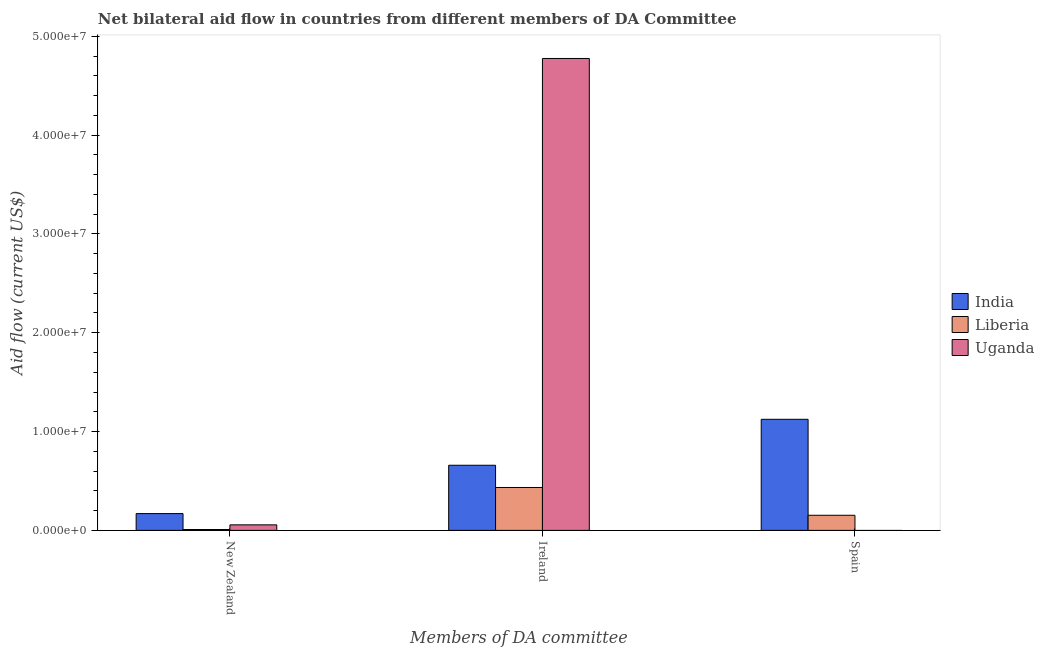How many different coloured bars are there?
Make the answer very short. 3. What is the label of the 2nd group of bars from the left?
Ensure brevity in your answer.  Ireland. What is the amount of aid provided by spain in India?
Make the answer very short. 1.12e+07. Across all countries, what is the maximum amount of aid provided by new zealand?
Your answer should be compact. 1.70e+06. Across all countries, what is the minimum amount of aid provided by ireland?
Make the answer very short. 4.34e+06. In which country was the amount of aid provided by ireland maximum?
Ensure brevity in your answer.  Uganda. What is the total amount of aid provided by new zealand in the graph?
Make the answer very short. 2.35e+06. What is the difference between the amount of aid provided by ireland in India and that in Uganda?
Give a very brief answer. -4.12e+07. What is the difference between the amount of aid provided by spain in Uganda and the amount of aid provided by new zealand in India?
Offer a very short reply. -1.70e+06. What is the average amount of aid provided by spain per country?
Provide a succinct answer. 4.26e+06. What is the difference between the amount of aid provided by spain and amount of aid provided by new zealand in India?
Keep it short and to the point. 9.54e+06. In how many countries, is the amount of aid provided by ireland greater than 28000000 US$?
Make the answer very short. 1. What is the ratio of the amount of aid provided by new zealand in India to that in Liberia?
Your answer should be very brief. 18.89. Is the amount of aid provided by new zealand in Liberia less than that in India?
Ensure brevity in your answer.  Yes. What is the difference between the highest and the second highest amount of aid provided by new zealand?
Provide a short and direct response. 1.14e+06. What is the difference between the highest and the lowest amount of aid provided by ireland?
Offer a very short reply. 4.34e+07. Is the sum of the amount of aid provided by ireland in Liberia and Uganda greater than the maximum amount of aid provided by spain across all countries?
Make the answer very short. Yes. Is it the case that in every country, the sum of the amount of aid provided by new zealand and amount of aid provided by ireland is greater than the amount of aid provided by spain?
Ensure brevity in your answer.  No. How many bars are there?
Your response must be concise. 8. Are all the bars in the graph horizontal?
Your answer should be compact. No. Does the graph contain grids?
Your answer should be very brief. No. Where does the legend appear in the graph?
Your answer should be very brief. Center right. How are the legend labels stacked?
Provide a short and direct response. Vertical. What is the title of the graph?
Provide a short and direct response. Net bilateral aid flow in countries from different members of DA Committee. What is the label or title of the X-axis?
Provide a succinct answer. Members of DA committee. What is the Aid flow (current US$) of India in New Zealand?
Give a very brief answer. 1.70e+06. What is the Aid flow (current US$) in Liberia in New Zealand?
Your answer should be very brief. 9.00e+04. What is the Aid flow (current US$) of Uganda in New Zealand?
Keep it short and to the point. 5.60e+05. What is the Aid flow (current US$) of India in Ireland?
Offer a terse response. 6.59e+06. What is the Aid flow (current US$) in Liberia in Ireland?
Your response must be concise. 4.34e+06. What is the Aid flow (current US$) in Uganda in Ireland?
Ensure brevity in your answer.  4.78e+07. What is the Aid flow (current US$) of India in Spain?
Give a very brief answer. 1.12e+07. What is the Aid flow (current US$) in Liberia in Spain?
Ensure brevity in your answer.  1.53e+06. What is the Aid flow (current US$) in Uganda in Spain?
Keep it short and to the point. 0. Across all Members of DA committee, what is the maximum Aid flow (current US$) in India?
Your response must be concise. 1.12e+07. Across all Members of DA committee, what is the maximum Aid flow (current US$) in Liberia?
Offer a terse response. 4.34e+06. Across all Members of DA committee, what is the maximum Aid flow (current US$) of Uganda?
Your response must be concise. 4.78e+07. Across all Members of DA committee, what is the minimum Aid flow (current US$) of India?
Give a very brief answer. 1.70e+06. Across all Members of DA committee, what is the minimum Aid flow (current US$) of Uganda?
Offer a terse response. 0. What is the total Aid flow (current US$) of India in the graph?
Provide a succinct answer. 1.95e+07. What is the total Aid flow (current US$) in Liberia in the graph?
Provide a short and direct response. 5.96e+06. What is the total Aid flow (current US$) of Uganda in the graph?
Your response must be concise. 4.83e+07. What is the difference between the Aid flow (current US$) in India in New Zealand and that in Ireland?
Give a very brief answer. -4.89e+06. What is the difference between the Aid flow (current US$) in Liberia in New Zealand and that in Ireland?
Your response must be concise. -4.25e+06. What is the difference between the Aid flow (current US$) of Uganda in New Zealand and that in Ireland?
Your response must be concise. -4.72e+07. What is the difference between the Aid flow (current US$) in India in New Zealand and that in Spain?
Make the answer very short. -9.54e+06. What is the difference between the Aid flow (current US$) of Liberia in New Zealand and that in Spain?
Provide a succinct answer. -1.44e+06. What is the difference between the Aid flow (current US$) of India in Ireland and that in Spain?
Ensure brevity in your answer.  -4.65e+06. What is the difference between the Aid flow (current US$) of Liberia in Ireland and that in Spain?
Ensure brevity in your answer.  2.81e+06. What is the difference between the Aid flow (current US$) in India in New Zealand and the Aid flow (current US$) in Liberia in Ireland?
Offer a terse response. -2.64e+06. What is the difference between the Aid flow (current US$) of India in New Zealand and the Aid flow (current US$) of Uganda in Ireland?
Offer a very short reply. -4.60e+07. What is the difference between the Aid flow (current US$) in Liberia in New Zealand and the Aid flow (current US$) in Uganda in Ireland?
Provide a short and direct response. -4.77e+07. What is the difference between the Aid flow (current US$) of India in Ireland and the Aid flow (current US$) of Liberia in Spain?
Ensure brevity in your answer.  5.06e+06. What is the average Aid flow (current US$) of India per Members of DA committee?
Your answer should be compact. 6.51e+06. What is the average Aid flow (current US$) in Liberia per Members of DA committee?
Provide a succinct answer. 1.99e+06. What is the average Aid flow (current US$) of Uganda per Members of DA committee?
Provide a short and direct response. 1.61e+07. What is the difference between the Aid flow (current US$) of India and Aid flow (current US$) of Liberia in New Zealand?
Provide a succinct answer. 1.61e+06. What is the difference between the Aid flow (current US$) in India and Aid flow (current US$) in Uganda in New Zealand?
Offer a terse response. 1.14e+06. What is the difference between the Aid flow (current US$) of Liberia and Aid flow (current US$) of Uganda in New Zealand?
Give a very brief answer. -4.70e+05. What is the difference between the Aid flow (current US$) of India and Aid flow (current US$) of Liberia in Ireland?
Ensure brevity in your answer.  2.25e+06. What is the difference between the Aid flow (current US$) in India and Aid flow (current US$) in Uganda in Ireland?
Offer a very short reply. -4.12e+07. What is the difference between the Aid flow (current US$) in Liberia and Aid flow (current US$) in Uganda in Ireland?
Give a very brief answer. -4.34e+07. What is the difference between the Aid flow (current US$) in India and Aid flow (current US$) in Liberia in Spain?
Offer a terse response. 9.71e+06. What is the ratio of the Aid flow (current US$) in India in New Zealand to that in Ireland?
Offer a terse response. 0.26. What is the ratio of the Aid flow (current US$) of Liberia in New Zealand to that in Ireland?
Provide a short and direct response. 0.02. What is the ratio of the Aid flow (current US$) in Uganda in New Zealand to that in Ireland?
Make the answer very short. 0.01. What is the ratio of the Aid flow (current US$) of India in New Zealand to that in Spain?
Make the answer very short. 0.15. What is the ratio of the Aid flow (current US$) of Liberia in New Zealand to that in Spain?
Give a very brief answer. 0.06. What is the ratio of the Aid flow (current US$) in India in Ireland to that in Spain?
Keep it short and to the point. 0.59. What is the ratio of the Aid flow (current US$) of Liberia in Ireland to that in Spain?
Offer a very short reply. 2.84. What is the difference between the highest and the second highest Aid flow (current US$) in India?
Keep it short and to the point. 4.65e+06. What is the difference between the highest and the second highest Aid flow (current US$) in Liberia?
Your answer should be very brief. 2.81e+06. What is the difference between the highest and the lowest Aid flow (current US$) in India?
Your response must be concise. 9.54e+06. What is the difference between the highest and the lowest Aid flow (current US$) in Liberia?
Your response must be concise. 4.25e+06. What is the difference between the highest and the lowest Aid flow (current US$) of Uganda?
Make the answer very short. 4.78e+07. 